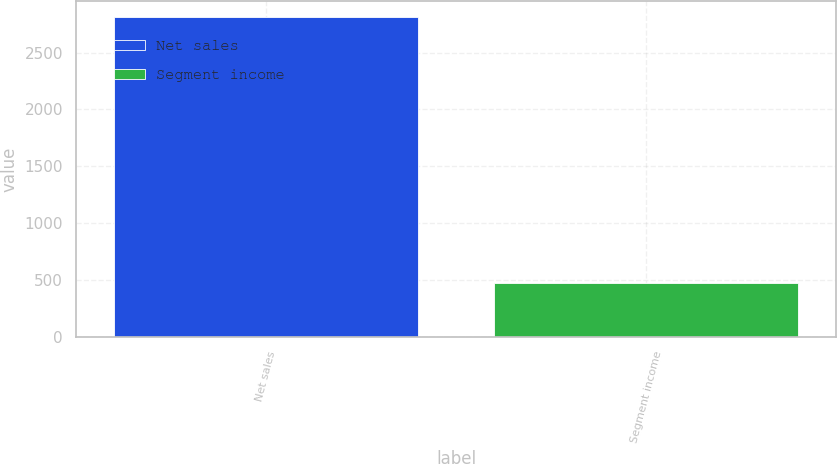Convert chart to OTSL. <chart><loc_0><loc_0><loc_500><loc_500><bar_chart><fcel>Net sales<fcel>Segment income<nl><fcel>2808.3<fcel>469<nl></chart> 